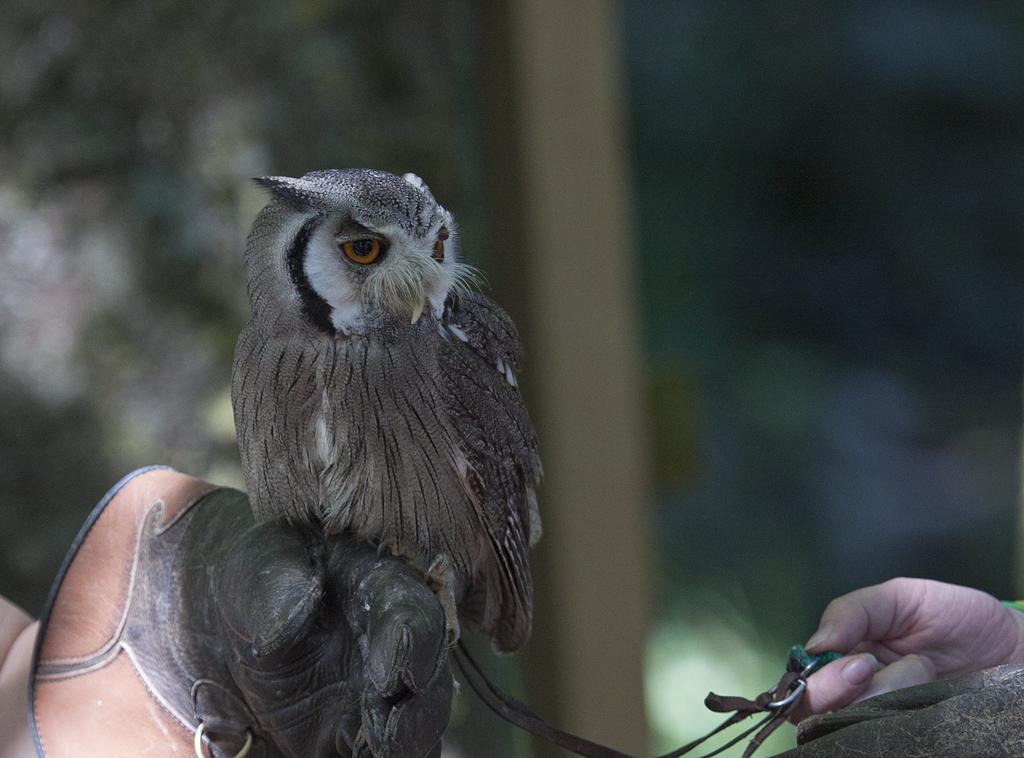Describe this image in one or two sentences. In this image we can see an owl on the hand of a person wearing a glove. On the right side we can see the hand of a person holding a belt. 